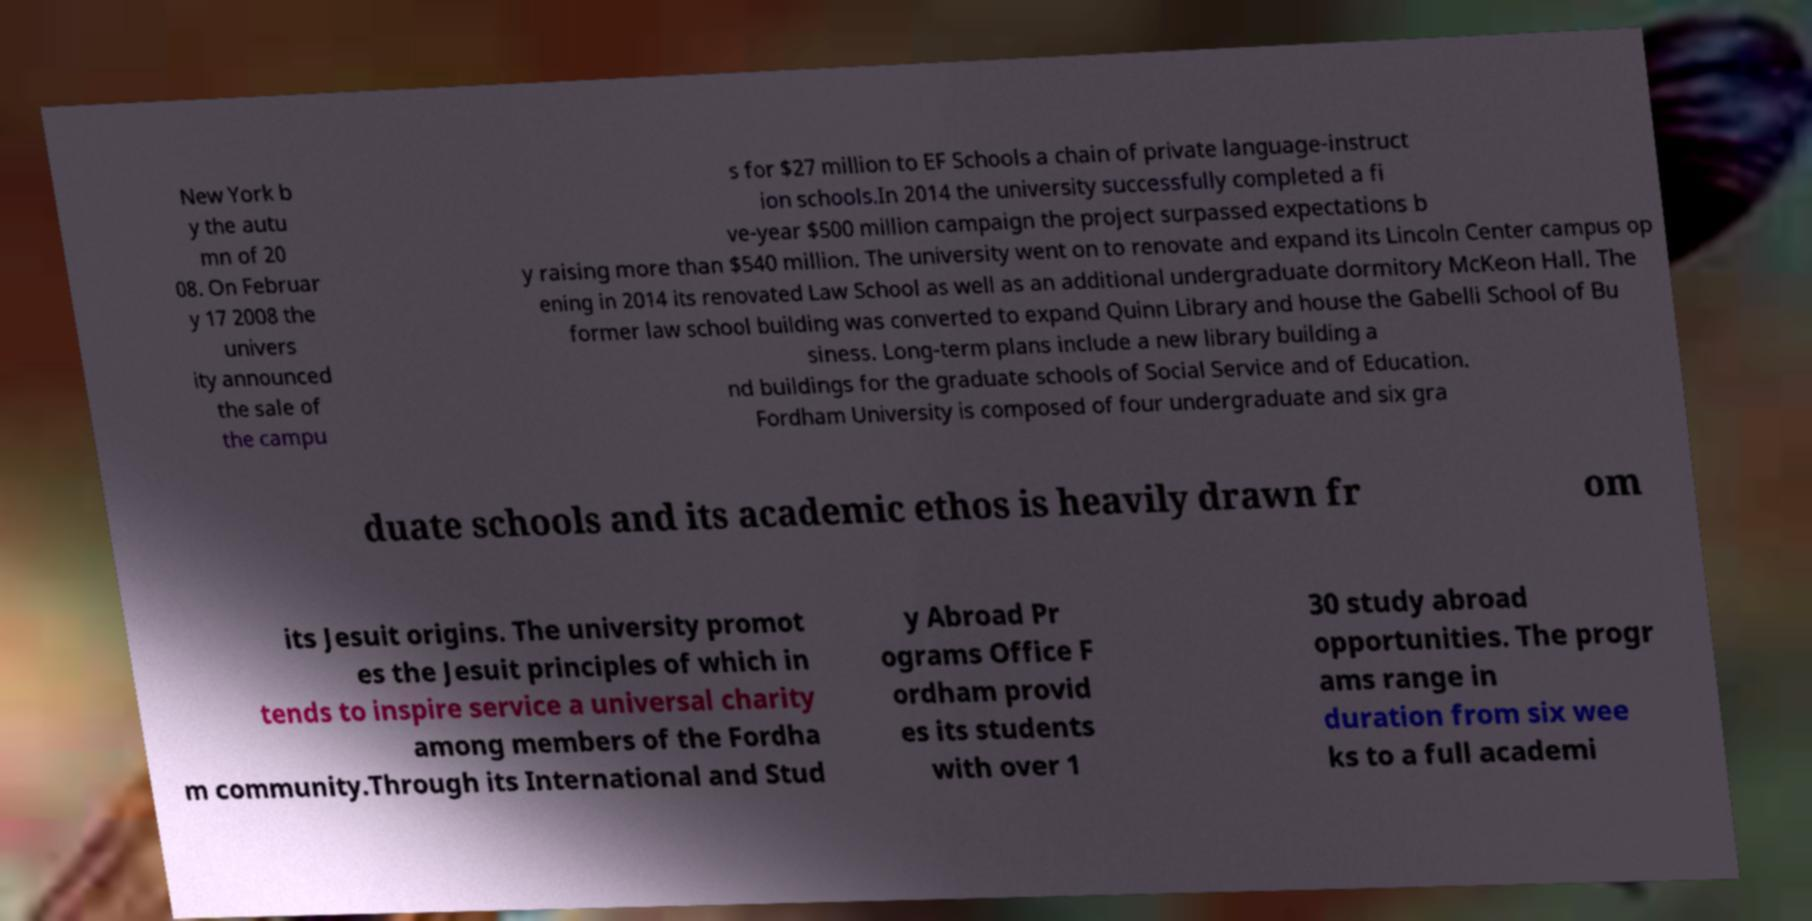Can you accurately transcribe the text from the provided image for me? New York b y the autu mn of 20 08. On Februar y 17 2008 the univers ity announced the sale of the campu s for $27 million to EF Schools a chain of private language-instruct ion schools.In 2014 the university successfully completed a fi ve-year $500 million campaign the project surpassed expectations b y raising more than $540 million. The university went on to renovate and expand its Lincoln Center campus op ening in 2014 its renovated Law School as well as an additional undergraduate dormitory McKeon Hall. The former law school building was converted to expand Quinn Library and house the Gabelli School of Bu siness. Long-term plans include a new library building a nd buildings for the graduate schools of Social Service and of Education. Fordham University is composed of four undergraduate and six gra duate schools and its academic ethos is heavily drawn fr om its Jesuit origins. The university promot es the Jesuit principles of which in tends to inspire service a universal charity among members of the Fordha m community.Through its International and Stud y Abroad Pr ograms Office F ordham provid es its students with over 1 30 study abroad opportunities. The progr ams range in duration from six wee ks to a full academi 